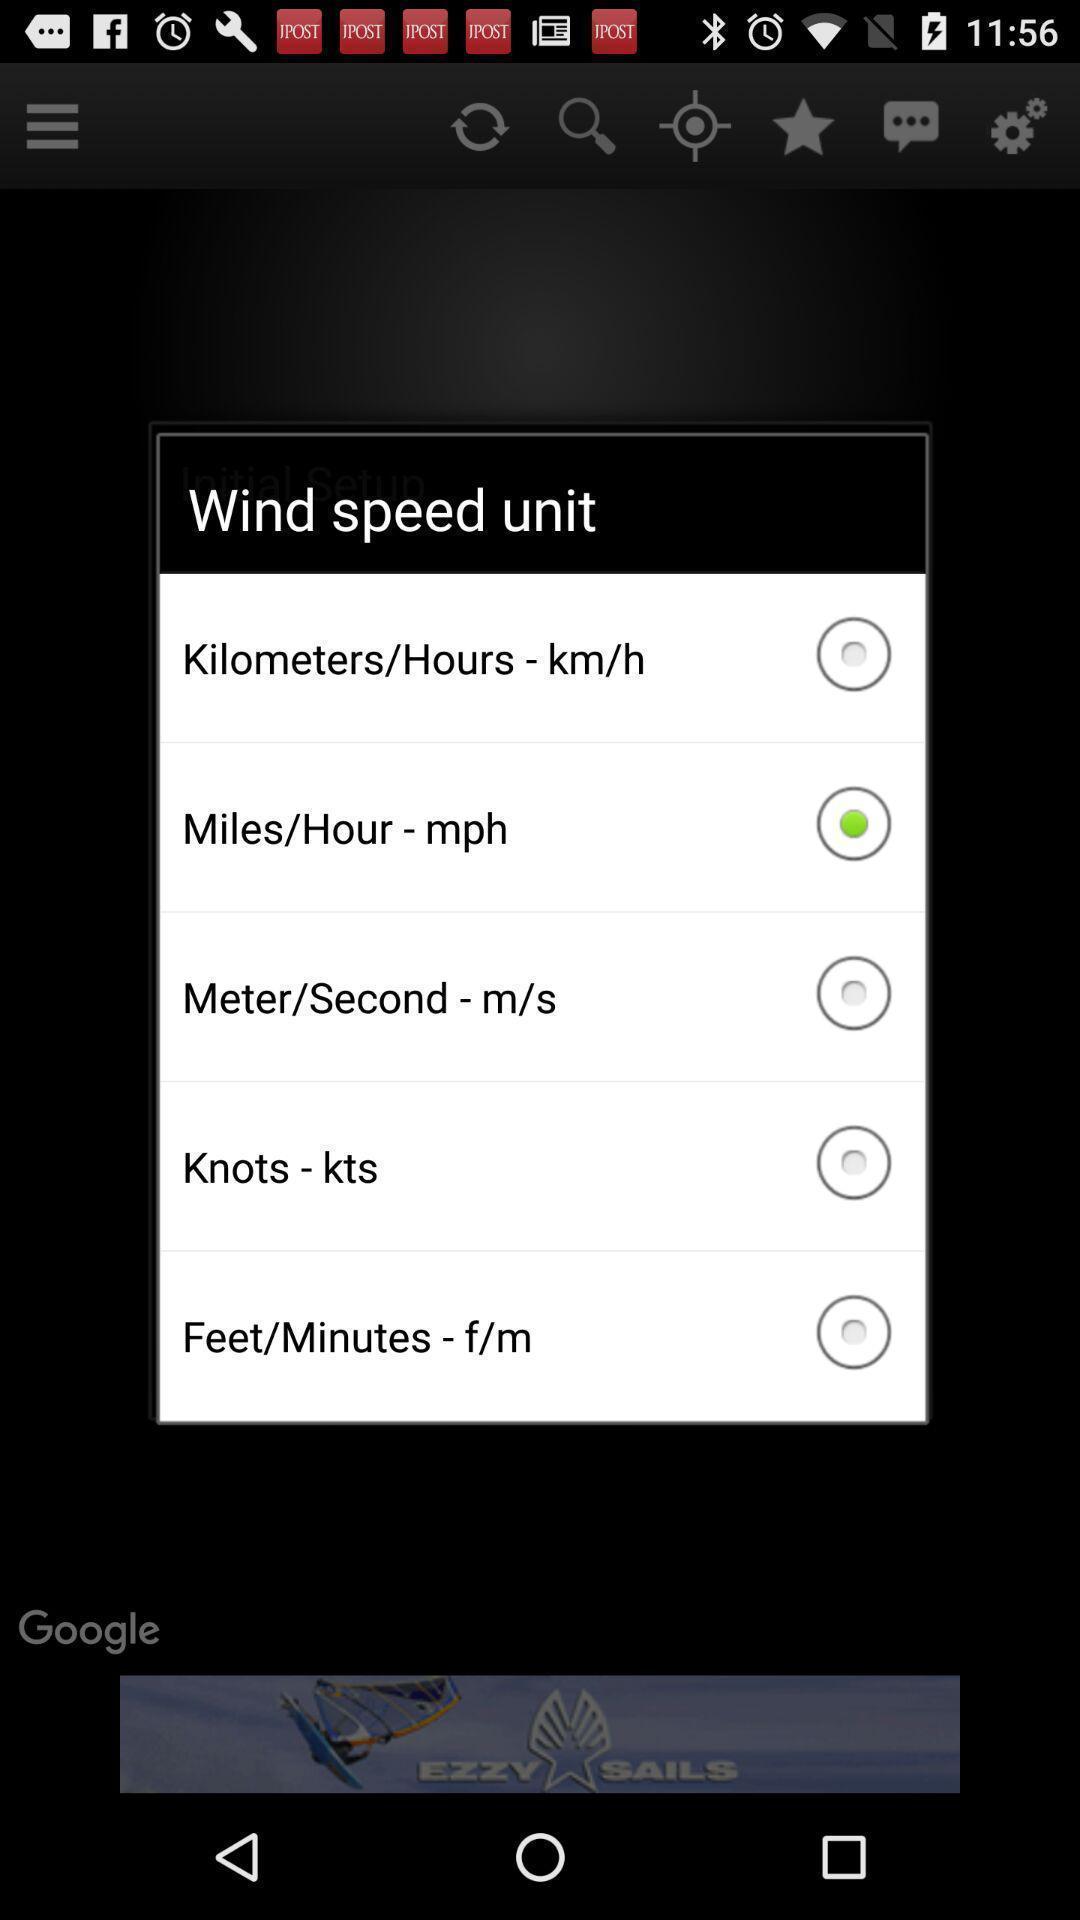What is the overall content of this screenshot? Pop up window with wind units. 